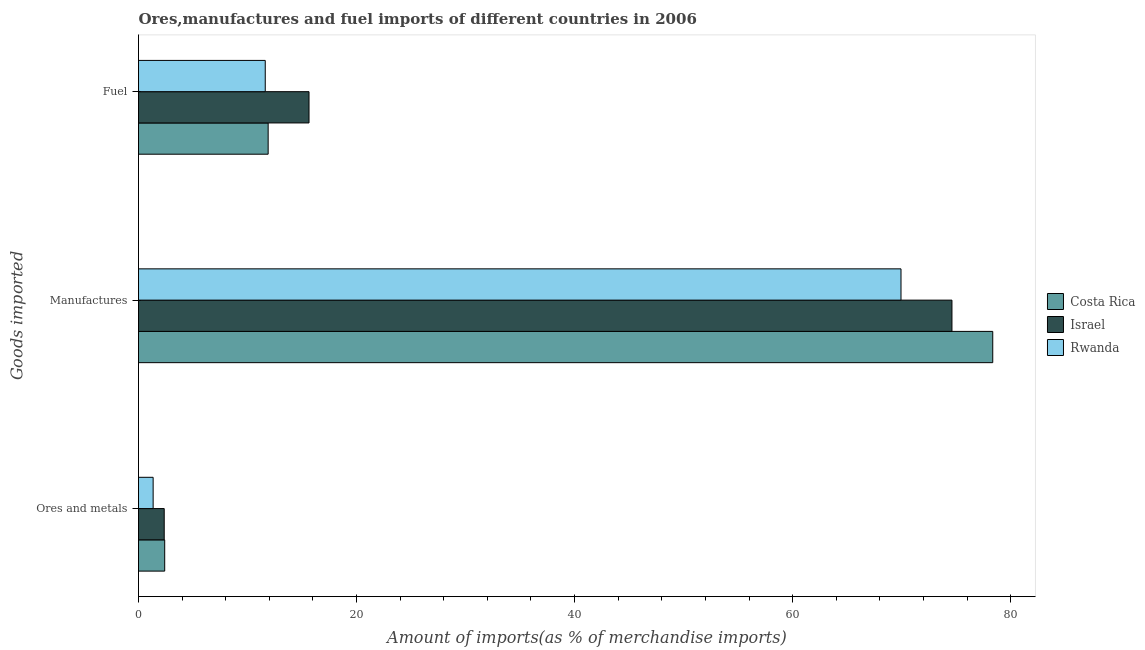How many different coloured bars are there?
Your response must be concise. 3. Are the number of bars per tick equal to the number of legend labels?
Provide a short and direct response. Yes. What is the label of the 1st group of bars from the top?
Your answer should be very brief. Fuel. What is the percentage of manufactures imports in Costa Rica?
Keep it short and to the point. 78.35. Across all countries, what is the maximum percentage of fuel imports?
Keep it short and to the point. 15.64. Across all countries, what is the minimum percentage of fuel imports?
Provide a short and direct response. 11.62. In which country was the percentage of manufactures imports maximum?
Make the answer very short. Costa Rica. In which country was the percentage of manufactures imports minimum?
Offer a terse response. Rwanda. What is the total percentage of manufactures imports in the graph?
Make the answer very short. 222.9. What is the difference between the percentage of manufactures imports in Costa Rica and that in Rwanda?
Provide a short and direct response. 8.41. What is the difference between the percentage of manufactures imports in Costa Rica and the percentage of fuel imports in Israel?
Offer a very short reply. 62.71. What is the average percentage of fuel imports per country?
Your answer should be compact. 13.05. What is the difference between the percentage of ores and metals imports and percentage of manufactures imports in Costa Rica?
Give a very brief answer. -75.95. In how many countries, is the percentage of manufactures imports greater than 60 %?
Offer a very short reply. 3. What is the ratio of the percentage of fuel imports in Israel to that in Rwanda?
Your response must be concise. 1.35. What is the difference between the highest and the second highest percentage of manufactures imports?
Your answer should be compact. 3.74. What is the difference between the highest and the lowest percentage of fuel imports?
Provide a short and direct response. 4.02. What does the 1st bar from the bottom in Fuel represents?
Offer a very short reply. Costa Rica. Is it the case that in every country, the sum of the percentage of ores and metals imports and percentage of manufactures imports is greater than the percentage of fuel imports?
Ensure brevity in your answer.  Yes. How many bars are there?
Offer a very short reply. 9. Are all the bars in the graph horizontal?
Ensure brevity in your answer.  Yes. How many countries are there in the graph?
Your answer should be compact. 3. What is the difference between two consecutive major ticks on the X-axis?
Give a very brief answer. 20. Are the values on the major ticks of X-axis written in scientific E-notation?
Provide a succinct answer. No. Does the graph contain grids?
Offer a terse response. No. How are the legend labels stacked?
Keep it short and to the point. Vertical. What is the title of the graph?
Your response must be concise. Ores,manufactures and fuel imports of different countries in 2006. Does "Botswana" appear as one of the legend labels in the graph?
Offer a terse response. No. What is the label or title of the X-axis?
Keep it short and to the point. Amount of imports(as % of merchandise imports). What is the label or title of the Y-axis?
Offer a terse response. Goods imported. What is the Amount of imports(as % of merchandise imports) of Costa Rica in Ores and metals?
Keep it short and to the point. 2.4. What is the Amount of imports(as % of merchandise imports) of Israel in Ores and metals?
Ensure brevity in your answer.  2.36. What is the Amount of imports(as % of merchandise imports) of Rwanda in Ores and metals?
Offer a terse response. 1.34. What is the Amount of imports(as % of merchandise imports) of Costa Rica in Manufactures?
Your response must be concise. 78.35. What is the Amount of imports(as % of merchandise imports) of Israel in Manufactures?
Your answer should be very brief. 74.61. What is the Amount of imports(as % of merchandise imports) of Rwanda in Manufactures?
Your response must be concise. 69.94. What is the Amount of imports(as % of merchandise imports) of Costa Rica in Fuel?
Keep it short and to the point. 11.89. What is the Amount of imports(as % of merchandise imports) in Israel in Fuel?
Offer a terse response. 15.64. What is the Amount of imports(as % of merchandise imports) in Rwanda in Fuel?
Keep it short and to the point. 11.62. Across all Goods imported, what is the maximum Amount of imports(as % of merchandise imports) in Costa Rica?
Provide a short and direct response. 78.35. Across all Goods imported, what is the maximum Amount of imports(as % of merchandise imports) in Israel?
Make the answer very short. 74.61. Across all Goods imported, what is the maximum Amount of imports(as % of merchandise imports) in Rwanda?
Your response must be concise. 69.94. Across all Goods imported, what is the minimum Amount of imports(as % of merchandise imports) of Costa Rica?
Provide a succinct answer. 2.4. Across all Goods imported, what is the minimum Amount of imports(as % of merchandise imports) in Israel?
Offer a very short reply. 2.36. Across all Goods imported, what is the minimum Amount of imports(as % of merchandise imports) of Rwanda?
Offer a very short reply. 1.34. What is the total Amount of imports(as % of merchandise imports) of Costa Rica in the graph?
Offer a very short reply. 92.65. What is the total Amount of imports(as % of merchandise imports) in Israel in the graph?
Make the answer very short. 92.61. What is the total Amount of imports(as % of merchandise imports) of Rwanda in the graph?
Offer a very short reply. 82.91. What is the difference between the Amount of imports(as % of merchandise imports) of Costa Rica in Ores and metals and that in Manufactures?
Provide a succinct answer. -75.95. What is the difference between the Amount of imports(as % of merchandise imports) in Israel in Ores and metals and that in Manufactures?
Ensure brevity in your answer.  -72.25. What is the difference between the Amount of imports(as % of merchandise imports) in Rwanda in Ores and metals and that in Manufactures?
Provide a succinct answer. -68.6. What is the difference between the Amount of imports(as % of merchandise imports) of Costa Rica in Ores and metals and that in Fuel?
Ensure brevity in your answer.  -9.49. What is the difference between the Amount of imports(as % of merchandise imports) of Israel in Ores and metals and that in Fuel?
Your answer should be very brief. -13.28. What is the difference between the Amount of imports(as % of merchandise imports) in Rwanda in Ores and metals and that in Fuel?
Provide a short and direct response. -10.28. What is the difference between the Amount of imports(as % of merchandise imports) of Costa Rica in Manufactures and that in Fuel?
Keep it short and to the point. 66.46. What is the difference between the Amount of imports(as % of merchandise imports) of Israel in Manufactures and that in Fuel?
Ensure brevity in your answer.  58.97. What is the difference between the Amount of imports(as % of merchandise imports) of Rwanda in Manufactures and that in Fuel?
Your answer should be compact. 58.31. What is the difference between the Amount of imports(as % of merchandise imports) of Costa Rica in Ores and metals and the Amount of imports(as % of merchandise imports) of Israel in Manufactures?
Offer a terse response. -72.21. What is the difference between the Amount of imports(as % of merchandise imports) in Costa Rica in Ores and metals and the Amount of imports(as % of merchandise imports) in Rwanda in Manufactures?
Ensure brevity in your answer.  -67.54. What is the difference between the Amount of imports(as % of merchandise imports) of Israel in Ores and metals and the Amount of imports(as % of merchandise imports) of Rwanda in Manufactures?
Offer a very short reply. -67.58. What is the difference between the Amount of imports(as % of merchandise imports) in Costa Rica in Ores and metals and the Amount of imports(as % of merchandise imports) in Israel in Fuel?
Provide a short and direct response. -13.24. What is the difference between the Amount of imports(as % of merchandise imports) in Costa Rica in Ores and metals and the Amount of imports(as % of merchandise imports) in Rwanda in Fuel?
Give a very brief answer. -9.22. What is the difference between the Amount of imports(as % of merchandise imports) of Israel in Ores and metals and the Amount of imports(as % of merchandise imports) of Rwanda in Fuel?
Provide a short and direct response. -9.27. What is the difference between the Amount of imports(as % of merchandise imports) of Costa Rica in Manufactures and the Amount of imports(as % of merchandise imports) of Israel in Fuel?
Provide a short and direct response. 62.71. What is the difference between the Amount of imports(as % of merchandise imports) in Costa Rica in Manufactures and the Amount of imports(as % of merchandise imports) in Rwanda in Fuel?
Provide a succinct answer. 66.73. What is the difference between the Amount of imports(as % of merchandise imports) in Israel in Manufactures and the Amount of imports(as % of merchandise imports) in Rwanda in Fuel?
Your answer should be compact. 62.99. What is the average Amount of imports(as % of merchandise imports) of Costa Rica per Goods imported?
Your answer should be very brief. 30.88. What is the average Amount of imports(as % of merchandise imports) in Israel per Goods imported?
Your response must be concise. 30.87. What is the average Amount of imports(as % of merchandise imports) in Rwanda per Goods imported?
Your response must be concise. 27.64. What is the difference between the Amount of imports(as % of merchandise imports) of Costa Rica and Amount of imports(as % of merchandise imports) of Israel in Ores and metals?
Offer a very short reply. 0.04. What is the difference between the Amount of imports(as % of merchandise imports) of Costa Rica and Amount of imports(as % of merchandise imports) of Rwanda in Ores and metals?
Provide a short and direct response. 1.06. What is the difference between the Amount of imports(as % of merchandise imports) of Israel and Amount of imports(as % of merchandise imports) of Rwanda in Ores and metals?
Keep it short and to the point. 1.02. What is the difference between the Amount of imports(as % of merchandise imports) of Costa Rica and Amount of imports(as % of merchandise imports) of Israel in Manufactures?
Keep it short and to the point. 3.74. What is the difference between the Amount of imports(as % of merchandise imports) in Costa Rica and Amount of imports(as % of merchandise imports) in Rwanda in Manufactures?
Offer a terse response. 8.41. What is the difference between the Amount of imports(as % of merchandise imports) in Israel and Amount of imports(as % of merchandise imports) in Rwanda in Manufactures?
Your answer should be compact. 4.67. What is the difference between the Amount of imports(as % of merchandise imports) in Costa Rica and Amount of imports(as % of merchandise imports) in Israel in Fuel?
Ensure brevity in your answer.  -3.75. What is the difference between the Amount of imports(as % of merchandise imports) of Costa Rica and Amount of imports(as % of merchandise imports) of Rwanda in Fuel?
Offer a terse response. 0.27. What is the difference between the Amount of imports(as % of merchandise imports) in Israel and Amount of imports(as % of merchandise imports) in Rwanda in Fuel?
Keep it short and to the point. 4.02. What is the ratio of the Amount of imports(as % of merchandise imports) of Costa Rica in Ores and metals to that in Manufactures?
Offer a very short reply. 0.03. What is the ratio of the Amount of imports(as % of merchandise imports) in Israel in Ores and metals to that in Manufactures?
Keep it short and to the point. 0.03. What is the ratio of the Amount of imports(as % of merchandise imports) in Rwanda in Ores and metals to that in Manufactures?
Provide a succinct answer. 0.02. What is the ratio of the Amount of imports(as % of merchandise imports) in Costa Rica in Ores and metals to that in Fuel?
Your answer should be compact. 0.2. What is the ratio of the Amount of imports(as % of merchandise imports) of Israel in Ores and metals to that in Fuel?
Give a very brief answer. 0.15. What is the ratio of the Amount of imports(as % of merchandise imports) in Rwanda in Ores and metals to that in Fuel?
Give a very brief answer. 0.12. What is the ratio of the Amount of imports(as % of merchandise imports) of Costa Rica in Manufactures to that in Fuel?
Your answer should be compact. 6.59. What is the ratio of the Amount of imports(as % of merchandise imports) of Israel in Manufactures to that in Fuel?
Make the answer very short. 4.77. What is the ratio of the Amount of imports(as % of merchandise imports) of Rwanda in Manufactures to that in Fuel?
Provide a succinct answer. 6.02. What is the difference between the highest and the second highest Amount of imports(as % of merchandise imports) of Costa Rica?
Provide a short and direct response. 66.46. What is the difference between the highest and the second highest Amount of imports(as % of merchandise imports) in Israel?
Provide a short and direct response. 58.97. What is the difference between the highest and the second highest Amount of imports(as % of merchandise imports) in Rwanda?
Offer a very short reply. 58.31. What is the difference between the highest and the lowest Amount of imports(as % of merchandise imports) of Costa Rica?
Give a very brief answer. 75.95. What is the difference between the highest and the lowest Amount of imports(as % of merchandise imports) in Israel?
Your answer should be very brief. 72.25. What is the difference between the highest and the lowest Amount of imports(as % of merchandise imports) of Rwanda?
Your response must be concise. 68.6. 